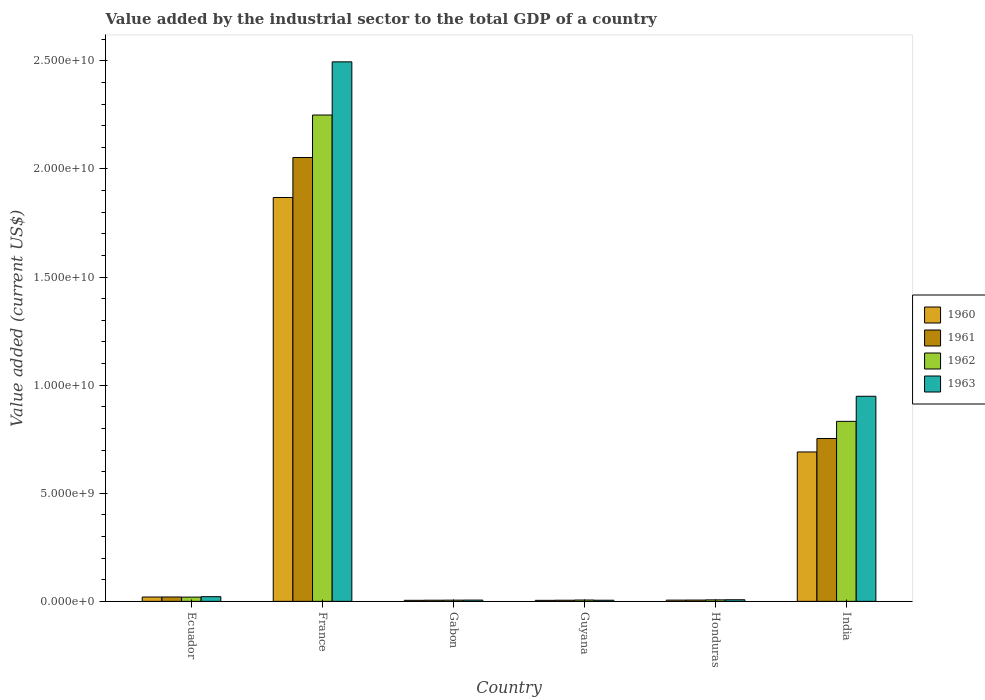How many different coloured bars are there?
Make the answer very short. 4. How many groups of bars are there?
Provide a short and direct response. 6. Are the number of bars per tick equal to the number of legend labels?
Your response must be concise. Yes. What is the label of the 2nd group of bars from the left?
Offer a very short reply. France. In how many cases, is the number of bars for a given country not equal to the number of legend labels?
Ensure brevity in your answer.  0. What is the value added by the industrial sector to the total GDP in 1961 in Gabon?
Ensure brevity in your answer.  5.29e+07. Across all countries, what is the maximum value added by the industrial sector to the total GDP in 1963?
Provide a short and direct response. 2.50e+1. Across all countries, what is the minimum value added by the industrial sector to the total GDP in 1961?
Provide a succinct answer. 5.23e+07. In which country was the value added by the industrial sector to the total GDP in 1962 minimum?
Give a very brief answer. Gabon. What is the total value added by the industrial sector to the total GDP in 1963 in the graph?
Ensure brevity in your answer.  3.48e+1. What is the difference between the value added by the industrial sector to the total GDP in 1962 in Ecuador and that in Honduras?
Offer a terse response. 1.27e+08. What is the difference between the value added by the industrial sector to the total GDP in 1963 in Guyana and the value added by the industrial sector to the total GDP in 1962 in France?
Give a very brief answer. -2.24e+1. What is the average value added by the industrial sector to the total GDP in 1963 per country?
Offer a terse response. 5.81e+09. What is the difference between the value added by the industrial sector to the total GDP of/in 1962 and value added by the industrial sector to the total GDP of/in 1960 in Ecuador?
Offer a very short reply. -4.47e+06. In how many countries, is the value added by the industrial sector to the total GDP in 1963 greater than 8000000000 US$?
Offer a very short reply. 2. What is the ratio of the value added by the industrial sector to the total GDP in 1960 in Guyana to that in Honduras?
Provide a short and direct response. 0.83. Is the value added by the industrial sector to the total GDP in 1963 in Honduras less than that in India?
Offer a very short reply. Yes. Is the difference between the value added by the industrial sector to the total GDP in 1962 in Ecuador and Guyana greater than the difference between the value added by the industrial sector to the total GDP in 1960 in Ecuador and Guyana?
Provide a short and direct response. No. What is the difference between the highest and the second highest value added by the industrial sector to the total GDP in 1960?
Provide a succinct answer. 6.71e+09. What is the difference between the highest and the lowest value added by the industrial sector to the total GDP in 1962?
Keep it short and to the point. 2.24e+1. In how many countries, is the value added by the industrial sector to the total GDP in 1960 greater than the average value added by the industrial sector to the total GDP in 1960 taken over all countries?
Ensure brevity in your answer.  2. Is it the case that in every country, the sum of the value added by the industrial sector to the total GDP in 1960 and value added by the industrial sector to the total GDP in 1963 is greater than the sum of value added by the industrial sector to the total GDP in 1961 and value added by the industrial sector to the total GDP in 1962?
Provide a succinct answer. No. What does the 2nd bar from the right in Guyana represents?
Your answer should be very brief. 1962. What is the difference between two consecutive major ticks on the Y-axis?
Provide a succinct answer. 5.00e+09. Where does the legend appear in the graph?
Keep it short and to the point. Center right. How are the legend labels stacked?
Ensure brevity in your answer.  Vertical. What is the title of the graph?
Offer a terse response. Value added by the industrial sector to the total GDP of a country. What is the label or title of the X-axis?
Keep it short and to the point. Country. What is the label or title of the Y-axis?
Give a very brief answer. Value added (current US$). What is the Value added (current US$) of 1960 in Ecuador?
Give a very brief answer. 2.01e+08. What is the Value added (current US$) in 1961 in Ecuador?
Offer a terse response. 2.02e+08. What is the Value added (current US$) of 1962 in Ecuador?
Make the answer very short. 1.96e+08. What is the Value added (current US$) of 1963 in Ecuador?
Keep it short and to the point. 2.16e+08. What is the Value added (current US$) of 1960 in France?
Keep it short and to the point. 1.87e+1. What is the Value added (current US$) in 1961 in France?
Offer a terse response. 2.05e+1. What is the Value added (current US$) of 1962 in France?
Your answer should be very brief. 2.25e+1. What is the Value added (current US$) in 1963 in France?
Provide a short and direct response. 2.50e+1. What is the Value added (current US$) of 1960 in Gabon?
Ensure brevity in your answer.  4.80e+07. What is the Value added (current US$) of 1961 in Gabon?
Make the answer very short. 5.29e+07. What is the Value added (current US$) of 1962 in Gabon?
Your answer should be very brief. 5.59e+07. What is the Value added (current US$) of 1963 in Gabon?
Provide a short and direct response. 5.89e+07. What is the Value added (current US$) of 1960 in Guyana?
Give a very brief answer. 4.74e+07. What is the Value added (current US$) of 1961 in Guyana?
Provide a succinct answer. 5.23e+07. What is the Value added (current US$) in 1962 in Guyana?
Offer a terse response. 6.20e+07. What is the Value added (current US$) in 1963 in Guyana?
Provide a short and direct response. 5.21e+07. What is the Value added (current US$) in 1960 in Honduras?
Offer a very short reply. 5.73e+07. What is the Value added (current US$) in 1961 in Honduras?
Provide a succinct answer. 5.94e+07. What is the Value added (current US$) of 1962 in Honduras?
Your response must be concise. 6.92e+07. What is the Value added (current US$) of 1963 in Honduras?
Give a very brief answer. 7.38e+07. What is the Value added (current US$) of 1960 in India?
Ensure brevity in your answer.  6.91e+09. What is the Value added (current US$) in 1961 in India?
Your answer should be compact. 7.53e+09. What is the Value added (current US$) in 1962 in India?
Ensure brevity in your answer.  8.33e+09. What is the Value added (current US$) of 1963 in India?
Provide a short and direct response. 9.49e+09. Across all countries, what is the maximum Value added (current US$) in 1960?
Your answer should be very brief. 1.87e+1. Across all countries, what is the maximum Value added (current US$) in 1961?
Your answer should be very brief. 2.05e+1. Across all countries, what is the maximum Value added (current US$) in 1962?
Offer a terse response. 2.25e+1. Across all countries, what is the maximum Value added (current US$) of 1963?
Your response must be concise. 2.50e+1. Across all countries, what is the minimum Value added (current US$) in 1960?
Make the answer very short. 4.74e+07. Across all countries, what is the minimum Value added (current US$) in 1961?
Your answer should be compact. 5.23e+07. Across all countries, what is the minimum Value added (current US$) in 1962?
Offer a terse response. 5.59e+07. Across all countries, what is the minimum Value added (current US$) in 1963?
Make the answer very short. 5.21e+07. What is the total Value added (current US$) in 1960 in the graph?
Your response must be concise. 2.59e+1. What is the total Value added (current US$) of 1961 in the graph?
Provide a succinct answer. 2.84e+1. What is the total Value added (current US$) of 1962 in the graph?
Make the answer very short. 3.12e+1. What is the total Value added (current US$) of 1963 in the graph?
Make the answer very short. 3.48e+1. What is the difference between the Value added (current US$) of 1960 in Ecuador and that in France?
Offer a terse response. -1.85e+1. What is the difference between the Value added (current US$) in 1961 in Ecuador and that in France?
Provide a short and direct response. -2.03e+1. What is the difference between the Value added (current US$) in 1962 in Ecuador and that in France?
Ensure brevity in your answer.  -2.23e+1. What is the difference between the Value added (current US$) of 1963 in Ecuador and that in France?
Your response must be concise. -2.47e+1. What is the difference between the Value added (current US$) of 1960 in Ecuador and that in Gabon?
Provide a short and direct response. 1.53e+08. What is the difference between the Value added (current US$) of 1961 in Ecuador and that in Gabon?
Your answer should be very brief. 1.49e+08. What is the difference between the Value added (current US$) in 1962 in Ecuador and that in Gabon?
Make the answer very short. 1.40e+08. What is the difference between the Value added (current US$) of 1963 in Ecuador and that in Gabon?
Offer a terse response. 1.57e+08. What is the difference between the Value added (current US$) of 1960 in Ecuador and that in Guyana?
Provide a short and direct response. 1.53e+08. What is the difference between the Value added (current US$) of 1961 in Ecuador and that in Guyana?
Give a very brief answer. 1.50e+08. What is the difference between the Value added (current US$) of 1962 in Ecuador and that in Guyana?
Ensure brevity in your answer.  1.34e+08. What is the difference between the Value added (current US$) of 1963 in Ecuador and that in Guyana?
Offer a terse response. 1.64e+08. What is the difference between the Value added (current US$) in 1960 in Ecuador and that in Honduras?
Your answer should be very brief. 1.43e+08. What is the difference between the Value added (current US$) in 1961 in Ecuador and that in Honduras?
Provide a short and direct response. 1.43e+08. What is the difference between the Value added (current US$) of 1962 in Ecuador and that in Honduras?
Your answer should be compact. 1.27e+08. What is the difference between the Value added (current US$) of 1963 in Ecuador and that in Honduras?
Provide a short and direct response. 1.42e+08. What is the difference between the Value added (current US$) of 1960 in Ecuador and that in India?
Your answer should be very brief. -6.71e+09. What is the difference between the Value added (current US$) in 1961 in Ecuador and that in India?
Offer a terse response. -7.33e+09. What is the difference between the Value added (current US$) in 1962 in Ecuador and that in India?
Your answer should be compact. -8.13e+09. What is the difference between the Value added (current US$) of 1963 in Ecuador and that in India?
Ensure brevity in your answer.  -9.27e+09. What is the difference between the Value added (current US$) of 1960 in France and that in Gabon?
Provide a short and direct response. 1.86e+1. What is the difference between the Value added (current US$) in 1961 in France and that in Gabon?
Keep it short and to the point. 2.05e+1. What is the difference between the Value added (current US$) in 1962 in France and that in Gabon?
Your response must be concise. 2.24e+1. What is the difference between the Value added (current US$) in 1963 in France and that in Gabon?
Your answer should be very brief. 2.49e+1. What is the difference between the Value added (current US$) of 1960 in France and that in Guyana?
Make the answer very short. 1.86e+1. What is the difference between the Value added (current US$) in 1961 in France and that in Guyana?
Give a very brief answer. 2.05e+1. What is the difference between the Value added (current US$) in 1962 in France and that in Guyana?
Offer a terse response. 2.24e+1. What is the difference between the Value added (current US$) in 1963 in France and that in Guyana?
Your response must be concise. 2.49e+1. What is the difference between the Value added (current US$) in 1960 in France and that in Honduras?
Provide a succinct answer. 1.86e+1. What is the difference between the Value added (current US$) in 1961 in France and that in Honduras?
Keep it short and to the point. 2.05e+1. What is the difference between the Value added (current US$) in 1962 in France and that in Honduras?
Provide a succinct answer. 2.24e+1. What is the difference between the Value added (current US$) in 1963 in France and that in Honduras?
Keep it short and to the point. 2.49e+1. What is the difference between the Value added (current US$) of 1960 in France and that in India?
Your answer should be compact. 1.18e+1. What is the difference between the Value added (current US$) of 1961 in France and that in India?
Give a very brief answer. 1.30e+1. What is the difference between the Value added (current US$) in 1962 in France and that in India?
Your response must be concise. 1.42e+1. What is the difference between the Value added (current US$) in 1963 in France and that in India?
Give a very brief answer. 1.55e+1. What is the difference between the Value added (current US$) of 1960 in Gabon and that in Guyana?
Ensure brevity in your answer.  5.58e+05. What is the difference between the Value added (current US$) in 1961 in Gabon and that in Guyana?
Your response must be concise. 6.49e+05. What is the difference between the Value added (current US$) of 1962 in Gabon and that in Guyana?
Give a very brief answer. -6.07e+06. What is the difference between the Value added (current US$) in 1963 in Gabon and that in Guyana?
Offer a very short reply. 6.82e+06. What is the difference between the Value added (current US$) in 1960 in Gabon and that in Honduras?
Your answer should be very brief. -9.32e+06. What is the difference between the Value added (current US$) in 1961 in Gabon and that in Honduras?
Offer a terse response. -6.43e+06. What is the difference between the Value added (current US$) of 1962 in Gabon and that in Honduras?
Your answer should be very brief. -1.33e+07. What is the difference between the Value added (current US$) in 1963 in Gabon and that in Honduras?
Provide a succinct answer. -1.49e+07. What is the difference between the Value added (current US$) in 1960 in Gabon and that in India?
Offer a very short reply. -6.86e+09. What is the difference between the Value added (current US$) of 1961 in Gabon and that in India?
Your response must be concise. -7.48e+09. What is the difference between the Value added (current US$) in 1962 in Gabon and that in India?
Offer a terse response. -8.27e+09. What is the difference between the Value added (current US$) in 1963 in Gabon and that in India?
Your response must be concise. -9.43e+09. What is the difference between the Value added (current US$) of 1960 in Guyana and that in Honduras?
Ensure brevity in your answer.  -9.88e+06. What is the difference between the Value added (current US$) in 1961 in Guyana and that in Honduras?
Your answer should be compact. -7.08e+06. What is the difference between the Value added (current US$) of 1962 in Guyana and that in Honduras?
Provide a succinct answer. -7.19e+06. What is the difference between the Value added (current US$) in 1963 in Guyana and that in Honduras?
Offer a terse response. -2.17e+07. What is the difference between the Value added (current US$) of 1960 in Guyana and that in India?
Provide a succinct answer. -6.86e+09. What is the difference between the Value added (current US$) in 1961 in Guyana and that in India?
Give a very brief answer. -7.48e+09. What is the difference between the Value added (current US$) of 1962 in Guyana and that in India?
Your answer should be compact. -8.26e+09. What is the difference between the Value added (current US$) in 1963 in Guyana and that in India?
Your answer should be compact. -9.43e+09. What is the difference between the Value added (current US$) of 1960 in Honduras and that in India?
Your response must be concise. -6.85e+09. What is the difference between the Value added (current US$) in 1961 in Honduras and that in India?
Your answer should be very brief. -7.47e+09. What is the difference between the Value added (current US$) in 1962 in Honduras and that in India?
Give a very brief answer. -8.26e+09. What is the difference between the Value added (current US$) in 1963 in Honduras and that in India?
Your answer should be compact. -9.41e+09. What is the difference between the Value added (current US$) of 1960 in Ecuador and the Value added (current US$) of 1961 in France?
Give a very brief answer. -2.03e+1. What is the difference between the Value added (current US$) of 1960 in Ecuador and the Value added (current US$) of 1962 in France?
Your response must be concise. -2.23e+1. What is the difference between the Value added (current US$) in 1960 in Ecuador and the Value added (current US$) in 1963 in France?
Your answer should be very brief. -2.48e+1. What is the difference between the Value added (current US$) in 1961 in Ecuador and the Value added (current US$) in 1962 in France?
Keep it short and to the point. -2.23e+1. What is the difference between the Value added (current US$) in 1961 in Ecuador and the Value added (current US$) in 1963 in France?
Give a very brief answer. -2.48e+1. What is the difference between the Value added (current US$) of 1962 in Ecuador and the Value added (current US$) of 1963 in France?
Provide a short and direct response. -2.48e+1. What is the difference between the Value added (current US$) of 1960 in Ecuador and the Value added (current US$) of 1961 in Gabon?
Provide a succinct answer. 1.48e+08. What is the difference between the Value added (current US$) of 1960 in Ecuador and the Value added (current US$) of 1962 in Gabon?
Give a very brief answer. 1.45e+08. What is the difference between the Value added (current US$) in 1960 in Ecuador and the Value added (current US$) in 1963 in Gabon?
Provide a short and direct response. 1.42e+08. What is the difference between the Value added (current US$) of 1961 in Ecuador and the Value added (current US$) of 1962 in Gabon?
Make the answer very short. 1.46e+08. What is the difference between the Value added (current US$) of 1961 in Ecuador and the Value added (current US$) of 1963 in Gabon?
Offer a very short reply. 1.43e+08. What is the difference between the Value added (current US$) in 1962 in Ecuador and the Value added (current US$) in 1963 in Gabon?
Make the answer very short. 1.37e+08. What is the difference between the Value added (current US$) of 1960 in Ecuador and the Value added (current US$) of 1961 in Guyana?
Provide a succinct answer. 1.48e+08. What is the difference between the Value added (current US$) of 1960 in Ecuador and the Value added (current US$) of 1962 in Guyana?
Offer a terse response. 1.39e+08. What is the difference between the Value added (current US$) of 1960 in Ecuador and the Value added (current US$) of 1963 in Guyana?
Your answer should be compact. 1.49e+08. What is the difference between the Value added (current US$) of 1961 in Ecuador and the Value added (current US$) of 1962 in Guyana?
Your answer should be compact. 1.40e+08. What is the difference between the Value added (current US$) in 1961 in Ecuador and the Value added (current US$) in 1963 in Guyana?
Your answer should be very brief. 1.50e+08. What is the difference between the Value added (current US$) in 1962 in Ecuador and the Value added (current US$) in 1963 in Guyana?
Offer a terse response. 1.44e+08. What is the difference between the Value added (current US$) in 1960 in Ecuador and the Value added (current US$) in 1961 in Honduras?
Provide a short and direct response. 1.41e+08. What is the difference between the Value added (current US$) in 1960 in Ecuador and the Value added (current US$) in 1962 in Honduras?
Offer a terse response. 1.31e+08. What is the difference between the Value added (current US$) in 1960 in Ecuador and the Value added (current US$) in 1963 in Honduras?
Provide a short and direct response. 1.27e+08. What is the difference between the Value added (current US$) in 1961 in Ecuador and the Value added (current US$) in 1962 in Honduras?
Provide a succinct answer. 1.33e+08. What is the difference between the Value added (current US$) of 1961 in Ecuador and the Value added (current US$) of 1963 in Honduras?
Offer a terse response. 1.28e+08. What is the difference between the Value added (current US$) in 1962 in Ecuador and the Value added (current US$) in 1963 in Honduras?
Offer a terse response. 1.22e+08. What is the difference between the Value added (current US$) in 1960 in Ecuador and the Value added (current US$) in 1961 in India?
Your answer should be very brief. -7.33e+09. What is the difference between the Value added (current US$) in 1960 in Ecuador and the Value added (current US$) in 1962 in India?
Provide a succinct answer. -8.13e+09. What is the difference between the Value added (current US$) of 1960 in Ecuador and the Value added (current US$) of 1963 in India?
Offer a terse response. -9.28e+09. What is the difference between the Value added (current US$) in 1961 in Ecuador and the Value added (current US$) in 1962 in India?
Offer a terse response. -8.12e+09. What is the difference between the Value added (current US$) of 1961 in Ecuador and the Value added (current US$) of 1963 in India?
Keep it short and to the point. -9.28e+09. What is the difference between the Value added (current US$) of 1962 in Ecuador and the Value added (current US$) of 1963 in India?
Keep it short and to the point. -9.29e+09. What is the difference between the Value added (current US$) of 1960 in France and the Value added (current US$) of 1961 in Gabon?
Offer a terse response. 1.86e+1. What is the difference between the Value added (current US$) of 1960 in France and the Value added (current US$) of 1962 in Gabon?
Keep it short and to the point. 1.86e+1. What is the difference between the Value added (current US$) in 1960 in France and the Value added (current US$) in 1963 in Gabon?
Offer a very short reply. 1.86e+1. What is the difference between the Value added (current US$) in 1961 in France and the Value added (current US$) in 1962 in Gabon?
Your answer should be compact. 2.05e+1. What is the difference between the Value added (current US$) of 1961 in France and the Value added (current US$) of 1963 in Gabon?
Provide a succinct answer. 2.05e+1. What is the difference between the Value added (current US$) of 1962 in France and the Value added (current US$) of 1963 in Gabon?
Keep it short and to the point. 2.24e+1. What is the difference between the Value added (current US$) of 1960 in France and the Value added (current US$) of 1961 in Guyana?
Keep it short and to the point. 1.86e+1. What is the difference between the Value added (current US$) in 1960 in France and the Value added (current US$) in 1962 in Guyana?
Your answer should be very brief. 1.86e+1. What is the difference between the Value added (current US$) in 1960 in France and the Value added (current US$) in 1963 in Guyana?
Make the answer very short. 1.86e+1. What is the difference between the Value added (current US$) of 1961 in France and the Value added (current US$) of 1962 in Guyana?
Make the answer very short. 2.05e+1. What is the difference between the Value added (current US$) of 1961 in France and the Value added (current US$) of 1963 in Guyana?
Offer a very short reply. 2.05e+1. What is the difference between the Value added (current US$) in 1962 in France and the Value added (current US$) in 1963 in Guyana?
Your answer should be compact. 2.24e+1. What is the difference between the Value added (current US$) of 1960 in France and the Value added (current US$) of 1961 in Honduras?
Your answer should be very brief. 1.86e+1. What is the difference between the Value added (current US$) in 1960 in France and the Value added (current US$) in 1962 in Honduras?
Ensure brevity in your answer.  1.86e+1. What is the difference between the Value added (current US$) in 1960 in France and the Value added (current US$) in 1963 in Honduras?
Keep it short and to the point. 1.86e+1. What is the difference between the Value added (current US$) in 1961 in France and the Value added (current US$) in 1962 in Honduras?
Keep it short and to the point. 2.05e+1. What is the difference between the Value added (current US$) of 1961 in France and the Value added (current US$) of 1963 in Honduras?
Offer a terse response. 2.05e+1. What is the difference between the Value added (current US$) in 1962 in France and the Value added (current US$) in 1963 in Honduras?
Give a very brief answer. 2.24e+1. What is the difference between the Value added (current US$) of 1960 in France and the Value added (current US$) of 1961 in India?
Ensure brevity in your answer.  1.11e+1. What is the difference between the Value added (current US$) of 1960 in France and the Value added (current US$) of 1962 in India?
Make the answer very short. 1.04e+1. What is the difference between the Value added (current US$) in 1960 in France and the Value added (current US$) in 1963 in India?
Offer a terse response. 9.19e+09. What is the difference between the Value added (current US$) of 1961 in France and the Value added (current US$) of 1962 in India?
Provide a succinct answer. 1.22e+1. What is the difference between the Value added (current US$) of 1961 in France and the Value added (current US$) of 1963 in India?
Make the answer very short. 1.10e+1. What is the difference between the Value added (current US$) in 1962 in France and the Value added (current US$) in 1963 in India?
Your answer should be compact. 1.30e+1. What is the difference between the Value added (current US$) in 1960 in Gabon and the Value added (current US$) in 1961 in Guyana?
Offer a very short reply. -4.28e+06. What is the difference between the Value added (current US$) of 1960 in Gabon and the Value added (current US$) of 1962 in Guyana?
Keep it short and to the point. -1.40e+07. What is the difference between the Value added (current US$) in 1960 in Gabon and the Value added (current US$) in 1963 in Guyana?
Offer a very short reply. -4.11e+06. What is the difference between the Value added (current US$) in 1961 in Gabon and the Value added (current US$) in 1962 in Guyana?
Provide a short and direct response. -9.09e+06. What is the difference between the Value added (current US$) in 1961 in Gabon and the Value added (current US$) in 1963 in Guyana?
Offer a terse response. 8.24e+05. What is the difference between the Value added (current US$) in 1962 in Gabon and the Value added (current US$) in 1963 in Guyana?
Offer a terse response. 3.85e+06. What is the difference between the Value added (current US$) in 1960 in Gabon and the Value added (current US$) in 1961 in Honduras?
Ensure brevity in your answer.  -1.14e+07. What is the difference between the Value added (current US$) of 1960 in Gabon and the Value added (current US$) of 1962 in Honduras?
Offer a very short reply. -2.12e+07. What is the difference between the Value added (current US$) of 1960 in Gabon and the Value added (current US$) of 1963 in Honduras?
Ensure brevity in your answer.  -2.58e+07. What is the difference between the Value added (current US$) in 1961 in Gabon and the Value added (current US$) in 1962 in Honduras?
Offer a very short reply. -1.63e+07. What is the difference between the Value added (current US$) of 1961 in Gabon and the Value added (current US$) of 1963 in Honduras?
Your response must be concise. -2.09e+07. What is the difference between the Value added (current US$) in 1962 in Gabon and the Value added (current US$) in 1963 in Honduras?
Provide a short and direct response. -1.79e+07. What is the difference between the Value added (current US$) of 1960 in Gabon and the Value added (current US$) of 1961 in India?
Your response must be concise. -7.48e+09. What is the difference between the Value added (current US$) of 1960 in Gabon and the Value added (current US$) of 1962 in India?
Make the answer very short. -8.28e+09. What is the difference between the Value added (current US$) of 1960 in Gabon and the Value added (current US$) of 1963 in India?
Offer a terse response. -9.44e+09. What is the difference between the Value added (current US$) in 1961 in Gabon and the Value added (current US$) in 1962 in India?
Keep it short and to the point. -8.27e+09. What is the difference between the Value added (current US$) of 1961 in Gabon and the Value added (current US$) of 1963 in India?
Your answer should be compact. -9.43e+09. What is the difference between the Value added (current US$) in 1962 in Gabon and the Value added (current US$) in 1963 in India?
Keep it short and to the point. -9.43e+09. What is the difference between the Value added (current US$) in 1960 in Guyana and the Value added (current US$) in 1961 in Honduras?
Your answer should be very brief. -1.19e+07. What is the difference between the Value added (current US$) of 1960 in Guyana and the Value added (current US$) of 1962 in Honduras?
Offer a terse response. -2.18e+07. What is the difference between the Value added (current US$) in 1960 in Guyana and the Value added (current US$) in 1963 in Honduras?
Offer a very short reply. -2.64e+07. What is the difference between the Value added (current US$) in 1961 in Guyana and the Value added (current US$) in 1962 in Honduras?
Your answer should be very brief. -1.69e+07. What is the difference between the Value added (current US$) in 1961 in Guyana and the Value added (current US$) in 1963 in Honduras?
Offer a very short reply. -2.15e+07. What is the difference between the Value added (current US$) of 1962 in Guyana and the Value added (current US$) of 1963 in Honduras?
Provide a succinct answer. -1.18e+07. What is the difference between the Value added (current US$) of 1960 in Guyana and the Value added (current US$) of 1961 in India?
Provide a succinct answer. -7.48e+09. What is the difference between the Value added (current US$) in 1960 in Guyana and the Value added (current US$) in 1962 in India?
Your answer should be very brief. -8.28e+09. What is the difference between the Value added (current US$) in 1960 in Guyana and the Value added (current US$) in 1963 in India?
Make the answer very short. -9.44e+09. What is the difference between the Value added (current US$) of 1961 in Guyana and the Value added (current US$) of 1962 in India?
Give a very brief answer. -8.27e+09. What is the difference between the Value added (current US$) in 1961 in Guyana and the Value added (current US$) in 1963 in India?
Offer a terse response. -9.43e+09. What is the difference between the Value added (current US$) in 1962 in Guyana and the Value added (current US$) in 1963 in India?
Make the answer very short. -9.42e+09. What is the difference between the Value added (current US$) of 1960 in Honduras and the Value added (current US$) of 1961 in India?
Provide a short and direct response. -7.47e+09. What is the difference between the Value added (current US$) of 1960 in Honduras and the Value added (current US$) of 1962 in India?
Your answer should be very brief. -8.27e+09. What is the difference between the Value added (current US$) in 1960 in Honduras and the Value added (current US$) in 1963 in India?
Make the answer very short. -9.43e+09. What is the difference between the Value added (current US$) in 1961 in Honduras and the Value added (current US$) in 1962 in India?
Provide a short and direct response. -8.27e+09. What is the difference between the Value added (current US$) of 1961 in Honduras and the Value added (current US$) of 1963 in India?
Your response must be concise. -9.43e+09. What is the difference between the Value added (current US$) in 1962 in Honduras and the Value added (current US$) in 1963 in India?
Keep it short and to the point. -9.42e+09. What is the average Value added (current US$) in 1960 per country?
Provide a short and direct response. 4.32e+09. What is the average Value added (current US$) of 1961 per country?
Ensure brevity in your answer.  4.74e+09. What is the average Value added (current US$) in 1962 per country?
Your answer should be very brief. 5.20e+09. What is the average Value added (current US$) of 1963 per country?
Your answer should be compact. 5.81e+09. What is the difference between the Value added (current US$) of 1960 and Value added (current US$) of 1961 in Ecuador?
Offer a very short reply. -1.51e+06. What is the difference between the Value added (current US$) in 1960 and Value added (current US$) in 1962 in Ecuador?
Your answer should be very brief. 4.47e+06. What is the difference between the Value added (current US$) of 1960 and Value added (current US$) of 1963 in Ecuador?
Ensure brevity in your answer.  -1.55e+07. What is the difference between the Value added (current US$) in 1961 and Value added (current US$) in 1962 in Ecuador?
Your answer should be compact. 5.98e+06. What is the difference between the Value added (current US$) of 1961 and Value added (current US$) of 1963 in Ecuador?
Keep it short and to the point. -1.39e+07. What is the difference between the Value added (current US$) of 1962 and Value added (current US$) of 1963 in Ecuador?
Offer a very short reply. -1.99e+07. What is the difference between the Value added (current US$) of 1960 and Value added (current US$) of 1961 in France?
Keep it short and to the point. -1.85e+09. What is the difference between the Value added (current US$) of 1960 and Value added (current US$) of 1962 in France?
Offer a terse response. -3.81e+09. What is the difference between the Value added (current US$) of 1960 and Value added (current US$) of 1963 in France?
Your answer should be compact. -6.27e+09. What is the difference between the Value added (current US$) in 1961 and Value added (current US$) in 1962 in France?
Offer a very short reply. -1.97e+09. What is the difference between the Value added (current US$) of 1961 and Value added (current US$) of 1963 in France?
Give a very brief answer. -4.42e+09. What is the difference between the Value added (current US$) of 1962 and Value added (current US$) of 1963 in France?
Offer a very short reply. -2.46e+09. What is the difference between the Value added (current US$) of 1960 and Value added (current US$) of 1961 in Gabon?
Your response must be concise. -4.93e+06. What is the difference between the Value added (current US$) of 1960 and Value added (current US$) of 1962 in Gabon?
Ensure brevity in your answer.  -7.96e+06. What is the difference between the Value added (current US$) of 1960 and Value added (current US$) of 1963 in Gabon?
Provide a short and direct response. -1.09e+07. What is the difference between the Value added (current US$) in 1961 and Value added (current US$) in 1962 in Gabon?
Your response must be concise. -3.02e+06. What is the difference between the Value added (current US$) of 1961 and Value added (current US$) of 1963 in Gabon?
Keep it short and to the point. -5.99e+06. What is the difference between the Value added (current US$) in 1962 and Value added (current US$) in 1963 in Gabon?
Your answer should be compact. -2.97e+06. What is the difference between the Value added (current US$) in 1960 and Value added (current US$) in 1961 in Guyana?
Ensure brevity in your answer.  -4.84e+06. What is the difference between the Value added (current US$) of 1960 and Value added (current US$) of 1962 in Guyana?
Give a very brief answer. -1.46e+07. What is the difference between the Value added (current US$) of 1960 and Value added (current US$) of 1963 in Guyana?
Your answer should be compact. -4.67e+06. What is the difference between the Value added (current US$) in 1961 and Value added (current US$) in 1962 in Guyana?
Make the answer very short. -9.74e+06. What is the difference between the Value added (current US$) in 1961 and Value added (current US$) in 1963 in Guyana?
Your answer should be very brief. 1.75e+05. What is the difference between the Value added (current US$) of 1962 and Value added (current US$) of 1963 in Guyana?
Give a very brief answer. 9.92e+06. What is the difference between the Value added (current US$) in 1960 and Value added (current US$) in 1961 in Honduras?
Give a very brief answer. -2.05e+06. What is the difference between the Value added (current US$) in 1960 and Value added (current US$) in 1962 in Honduras?
Give a very brief answer. -1.19e+07. What is the difference between the Value added (current US$) in 1960 and Value added (current US$) in 1963 in Honduras?
Your answer should be very brief. -1.65e+07. What is the difference between the Value added (current US$) of 1961 and Value added (current US$) of 1962 in Honduras?
Keep it short and to the point. -9.85e+06. What is the difference between the Value added (current US$) of 1961 and Value added (current US$) of 1963 in Honduras?
Your answer should be very brief. -1.44e+07. What is the difference between the Value added (current US$) in 1962 and Value added (current US$) in 1963 in Honduras?
Offer a very short reply. -4.60e+06. What is the difference between the Value added (current US$) in 1960 and Value added (current US$) in 1961 in India?
Offer a very short reply. -6.21e+08. What is the difference between the Value added (current US$) of 1960 and Value added (current US$) of 1962 in India?
Provide a succinct answer. -1.42e+09. What is the difference between the Value added (current US$) of 1960 and Value added (current US$) of 1963 in India?
Make the answer very short. -2.58e+09. What is the difference between the Value added (current US$) of 1961 and Value added (current US$) of 1962 in India?
Ensure brevity in your answer.  -7.94e+08. What is the difference between the Value added (current US$) in 1961 and Value added (current US$) in 1963 in India?
Offer a very short reply. -1.95e+09. What is the difference between the Value added (current US$) in 1962 and Value added (current US$) in 1963 in India?
Provide a succinct answer. -1.16e+09. What is the ratio of the Value added (current US$) of 1960 in Ecuador to that in France?
Your answer should be compact. 0.01. What is the ratio of the Value added (current US$) in 1961 in Ecuador to that in France?
Your answer should be compact. 0.01. What is the ratio of the Value added (current US$) of 1962 in Ecuador to that in France?
Provide a short and direct response. 0.01. What is the ratio of the Value added (current US$) in 1963 in Ecuador to that in France?
Ensure brevity in your answer.  0.01. What is the ratio of the Value added (current US$) in 1960 in Ecuador to that in Gabon?
Your answer should be very brief. 4.18. What is the ratio of the Value added (current US$) in 1961 in Ecuador to that in Gabon?
Provide a short and direct response. 3.82. What is the ratio of the Value added (current US$) in 1962 in Ecuador to that in Gabon?
Ensure brevity in your answer.  3.51. What is the ratio of the Value added (current US$) in 1963 in Ecuador to that in Gabon?
Your answer should be compact. 3.67. What is the ratio of the Value added (current US$) in 1960 in Ecuador to that in Guyana?
Give a very brief answer. 4.23. What is the ratio of the Value added (current US$) of 1961 in Ecuador to that in Guyana?
Your answer should be very brief. 3.87. What is the ratio of the Value added (current US$) in 1962 in Ecuador to that in Guyana?
Offer a very short reply. 3.16. What is the ratio of the Value added (current US$) in 1963 in Ecuador to that in Guyana?
Make the answer very short. 4.15. What is the ratio of the Value added (current US$) in 1960 in Ecuador to that in Honduras?
Your answer should be very brief. 3.5. What is the ratio of the Value added (current US$) in 1961 in Ecuador to that in Honduras?
Make the answer very short. 3.41. What is the ratio of the Value added (current US$) of 1962 in Ecuador to that in Honduras?
Your response must be concise. 2.83. What is the ratio of the Value added (current US$) of 1963 in Ecuador to that in Honduras?
Your answer should be compact. 2.93. What is the ratio of the Value added (current US$) in 1960 in Ecuador to that in India?
Offer a very short reply. 0.03. What is the ratio of the Value added (current US$) of 1961 in Ecuador to that in India?
Make the answer very short. 0.03. What is the ratio of the Value added (current US$) of 1962 in Ecuador to that in India?
Give a very brief answer. 0.02. What is the ratio of the Value added (current US$) of 1963 in Ecuador to that in India?
Keep it short and to the point. 0.02. What is the ratio of the Value added (current US$) of 1960 in France to that in Gabon?
Your answer should be very brief. 389.29. What is the ratio of the Value added (current US$) in 1961 in France to that in Gabon?
Your answer should be compact. 387.95. What is the ratio of the Value added (current US$) of 1962 in France to that in Gabon?
Provide a succinct answer. 402.11. What is the ratio of the Value added (current US$) of 1963 in France to that in Gabon?
Your answer should be compact. 423.59. What is the ratio of the Value added (current US$) in 1960 in France to that in Guyana?
Your answer should be very brief. 393.87. What is the ratio of the Value added (current US$) of 1961 in France to that in Guyana?
Your answer should be very brief. 392.77. What is the ratio of the Value added (current US$) of 1962 in France to that in Guyana?
Give a very brief answer. 362.76. What is the ratio of the Value added (current US$) in 1963 in France to that in Guyana?
Provide a succinct answer. 479.03. What is the ratio of the Value added (current US$) of 1960 in France to that in Honduras?
Keep it short and to the point. 325.99. What is the ratio of the Value added (current US$) in 1961 in France to that in Honduras?
Your response must be concise. 345.89. What is the ratio of the Value added (current US$) in 1962 in France to that in Honduras?
Your response must be concise. 325.06. What is the ratio of the Value added (current US$) of 1963 in France to that in Honduras?
Provide a short and direct response. 338.12. What is the ratio of the Value added (current US$) in 1960 in France to that in India?
Offer a terse response. 2.7. What is the ratio of the Value added (current US$) in 1961 in France to that in India?
Provide a short and direct response. 2.73. What is the ratio of the Value added (current US$) of 1962 in France to that in India?
Ensure brevity in your answer.  2.7. What is the ratio of the Value added (current US$) in 1963 in France to that in India?
Give a very brief answer. 2.63. What is the ratio of the Value added (current US$) of 1960 in Gabon to that in Guyana?
Provide a short and direct response. 1.01. What is the ratio of the Value added (current US$) in 1961 in Gabon to that in Guyana?
Your answer should be compact. 1.01. What is the ratio of the Value added (current US$) of 1962 in Gabon to that in Guyana?
Provide a short and direct response. 0.9. What is the ratio of the Value added (current US$) in 1963 in Gabon to that in Guyana?
Provide a succinct answer. 1.13. What is the ratio of the Value added (current US$) in 1960 in Gabon to that in Honduras?
Keep it short and to the point. 0.84. What is the ratio of the Value added (current US$) of 1961 in Gabon to that in Honduras?
Your response must be concise. 0.89. What is the ratio of the Value added (current US$) of 1962 in Gabon to that in Honduras?
Offer a terse response. 0.81. What is the ratio of the Value added (current US$) in 1963 in Gabon to that in Honduras?
Offer a very short reply. 0.8. What is the ratio of the Value added (current US$) in 1960 in Gabon to that in India?
Ensure brevity in your answer.  0.01. What is the ratio of the Value added (current US$) of 1961 in Gabon to that in India?
Ensure brevity in your answer.  0.01. What is the ratio of the Value added (current US$) of 1962 in Gabon to that in India?
Your answer should be compact. 0.01. What is the ratio of the Value added (current US$) of 1963 in Gabon to that in India?
Provide a short and direct response. 0.01. What is the ratio of the Value added (current US$) of 1960 in Guyana to that in Honduras?
Your answer should be compact. 0.83. What is the ratio of the Value added (current US$) of 1961 in Guyana to that in Honduras?
Your answer should be very brief. 0.88. What is the ratio of the Value added (current US$) of 1962 in Guyana to that in Honduras?
Provide a succinct answer. 0.9. What is the ratio of the Value added (current US$) in 1963 in Guyana to that in Honduras?
Your answer should be compact. 0.71. What is the ratio of the Value added (current US$) in 1960 in Guyana to that in India?
Your answer should be compact. 0.01. What is the ratio of the Value added (current US$) of 1961 in Guyana to that in India?
Keep it short and to the point. 0.01. What is the ratio of the Value added (current US$) of 1962 in Guyana to that in India?
Offer a terse response. 0.01. What is the ratio of the Value added (current US$) in 1963 in Guyana to that in India?
Offer a terse response. 0.01. What is the ratio of the Value added (current US$) in 1960 in Honduras to that in India?
Offer a terse response. 0.01. What is the ratio of the Value added (current US$) in 1961 in Honduras to that in India?
Your response must be concise. 0.01. What is the ratio of the Value added (current US$) in 1962 in Honduras to that in India?
Keep it short and to the point. 0.01. What is the ratio of the Value added (current US$) of 1963 in Honduras to that in India?
Provide a short and direct response. 0.01. What is the difference between the highest and the second highest Value added (current US$) of 1960?
Your response must be concise. 1.18e+1. What is the difference between the highest and the second highest Value added (current US$) of 1961?
Give a very brief answer. 1.30e+1. What is the difference between the highest and the second highest Value added (current US$) in 1962?
Provide a short and direct response. 1.42e+1. What is the difference between the highest and the second highest Value added (current US$) of 1963?
Give a very brief answer. 1.55e+1. What is the difference between the highest and the lowest Value added (current US$) in 1960?
Keep it short and to the point. 1.86e+1. What is the difference between the highest and the lowest Value added (current US$) in 1961?
Your answer should be very brief. 2.05e+1. What is the difference between the highest and the lowest Value added (current US$) of 1962?
Your response must be concise. 2.24e+1. What is the difference between the highest and the lowest Value added (current US$) of 1963?
Your answer should be very brief. 2.49e+1. 